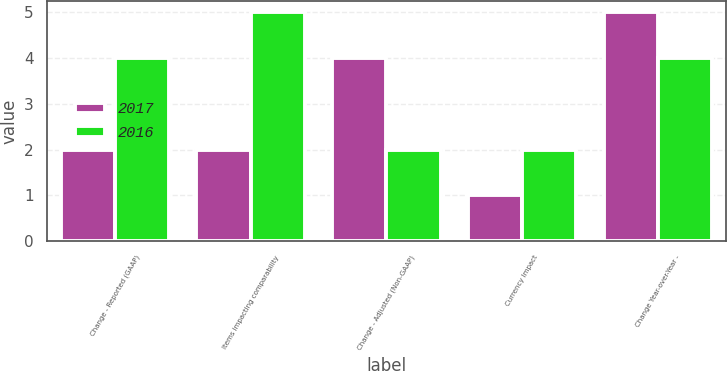Convert chart to OTSL. <chart><loc_0><loc_0><loc_500><loc_500><stacked_bar_chart><ecel><fcel>Change - Reported (GAAP)<fcel>Items impacting comparability<fcel>Change - Adjusted (Non-GAAP)<fcel>Currency Impact<fcel>Change Year-over-Year -<nl><fcel>2017<fcel>2<fcel>2<fcel>4<fcel>1<fcel>5<nl><fcel>2016<fcel>4<fcel>5<fcel>2<fcel>2<fcel>4<nl></chart> 